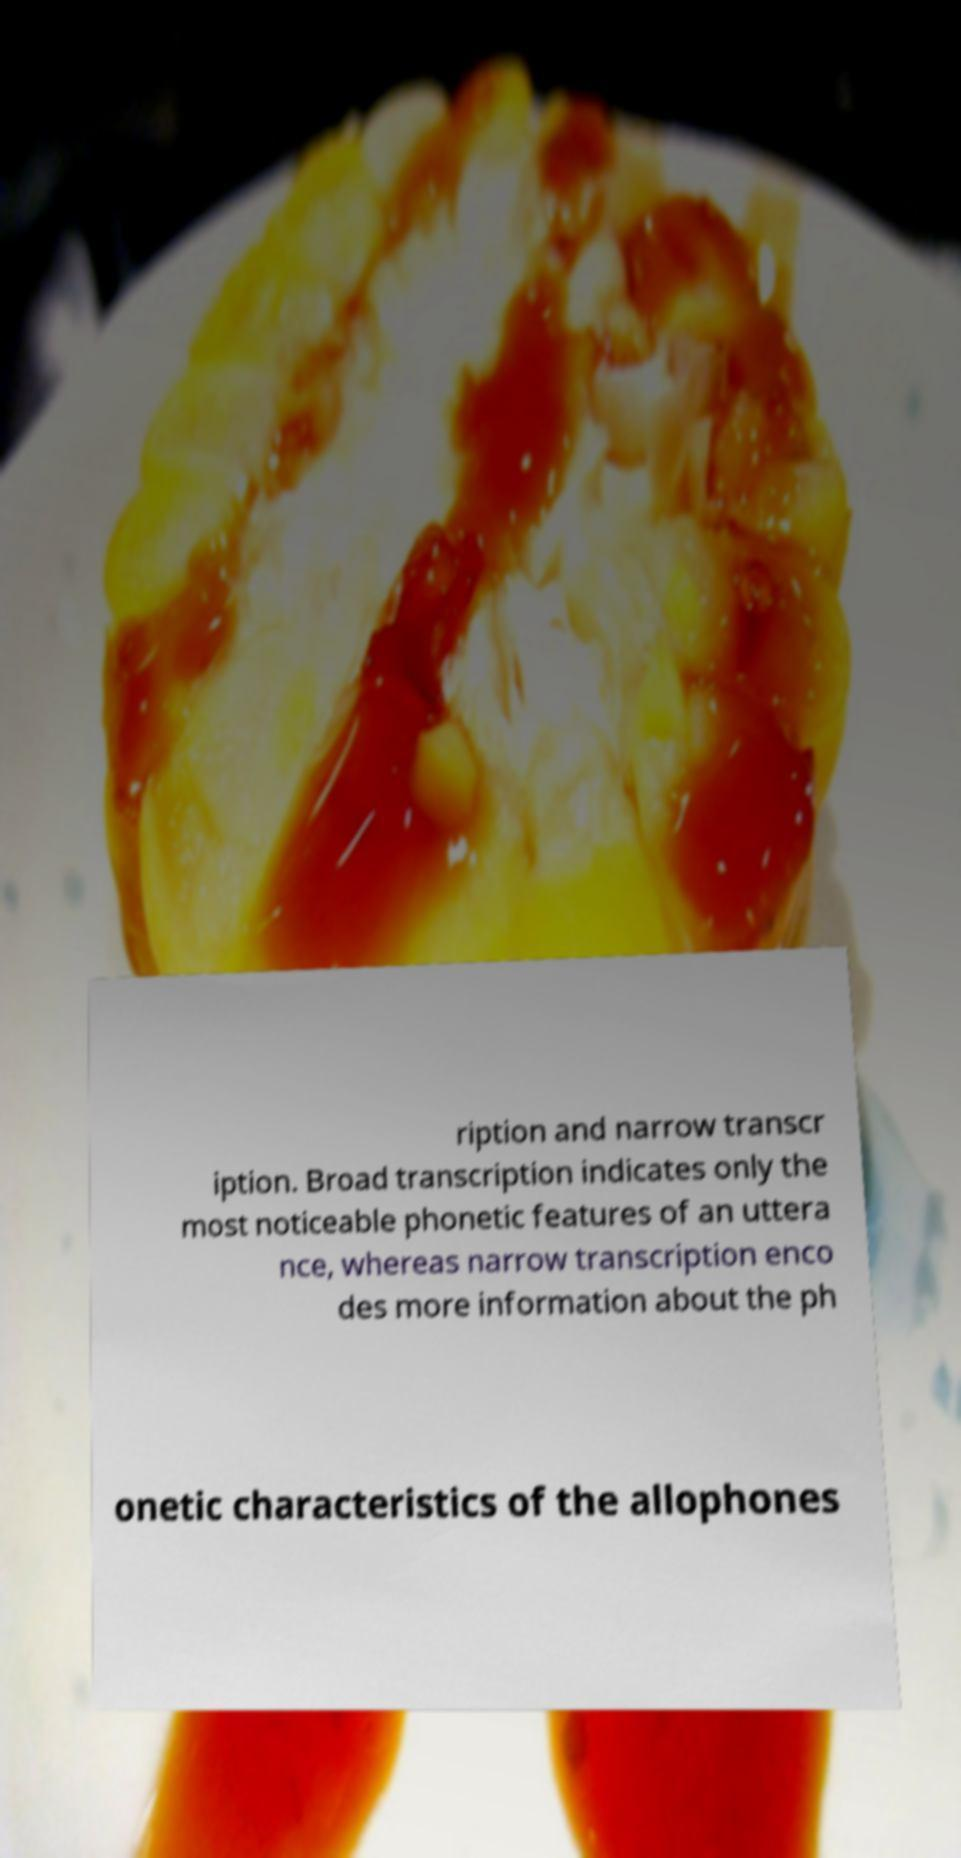I need the written content from this picture converted into text. Can you do that? ription and narrow transcr iption. Broad transcription indicates only the most noticeable phonetic features of an uttera nce, whereas narrow transcription enco des more information about the ph onetic characteristics of the allophones 